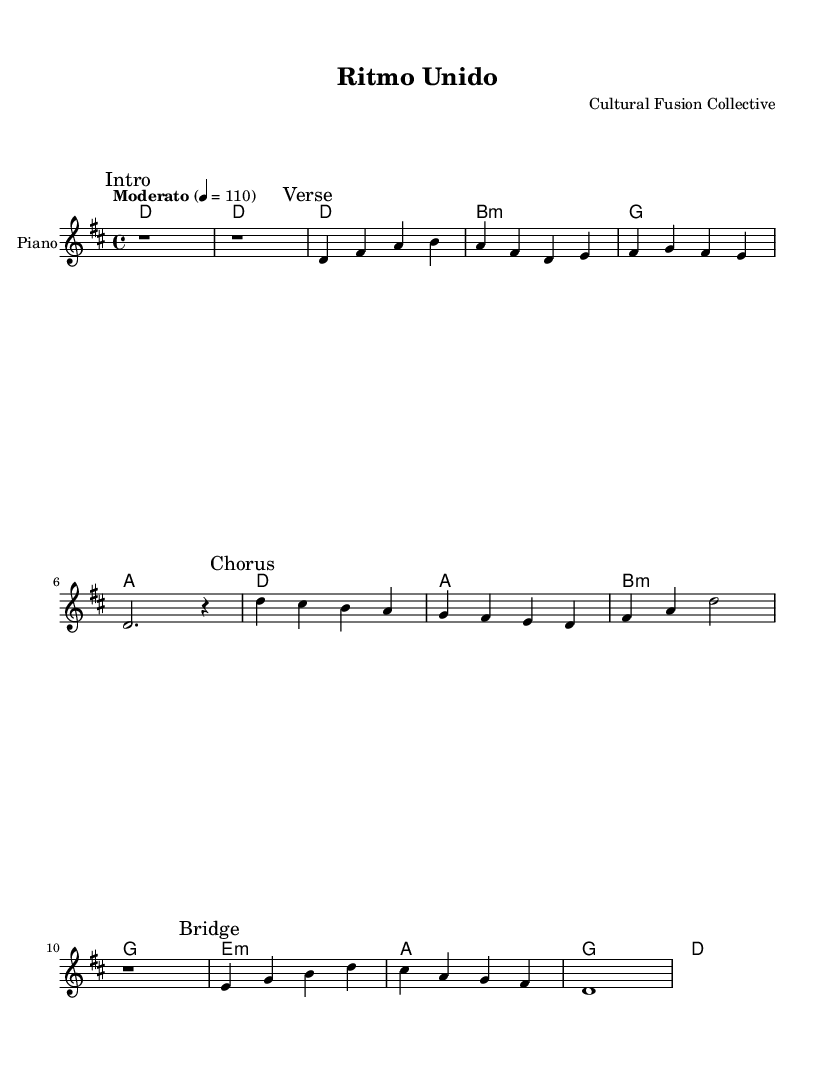What is the key signature of this music? The key signature is D major, which contains two sharps (F# and C#). This can be determined from the initial indication in the piece where the key is stated.
Answer: D major What is the time signature of this music? The time signature is 4/4, indicated at the beginning of the score. This means there are four beats in each measure, and the quarter note receives one beat.
Answer: 4/4 What is the tempo marking for the piece? The tempo marking is "Moderato," indicating a moderate speed. Additionally, the rhythmic marking "4 = 110" suggests 110 beats per minute, correlating with the definition of moderato.
Answer: Moderato What chord is played in the first measure of the verse? The chord in the first measure of the verse is D major. This is found in the chord names section, as it directly corresponds to the melody at that point.
Answer: D How many measures are in the chorus of the piece? The chorus section consists of four measures, as indicated by the notations under the "Chorus" mark. Each of the four musical phrases corresponds to one measure, confirming the total.
Answer: 4 Which type of chord appears most frequently in the structure? The B minor chord appears most frequently as it is repeated in both the verse and the chorus sections. Counting occurrences shows that it appears a total of three times across these sections.
Answer: B minor What aspect of this music promotes cultural diversity? The incorporation of various Latin pop elements blended with contemporary styles promotes cultural diversity, showcasing a mixture of rhythms and influences that celebrate different cultural backgrounds.
Answer: Fusion 